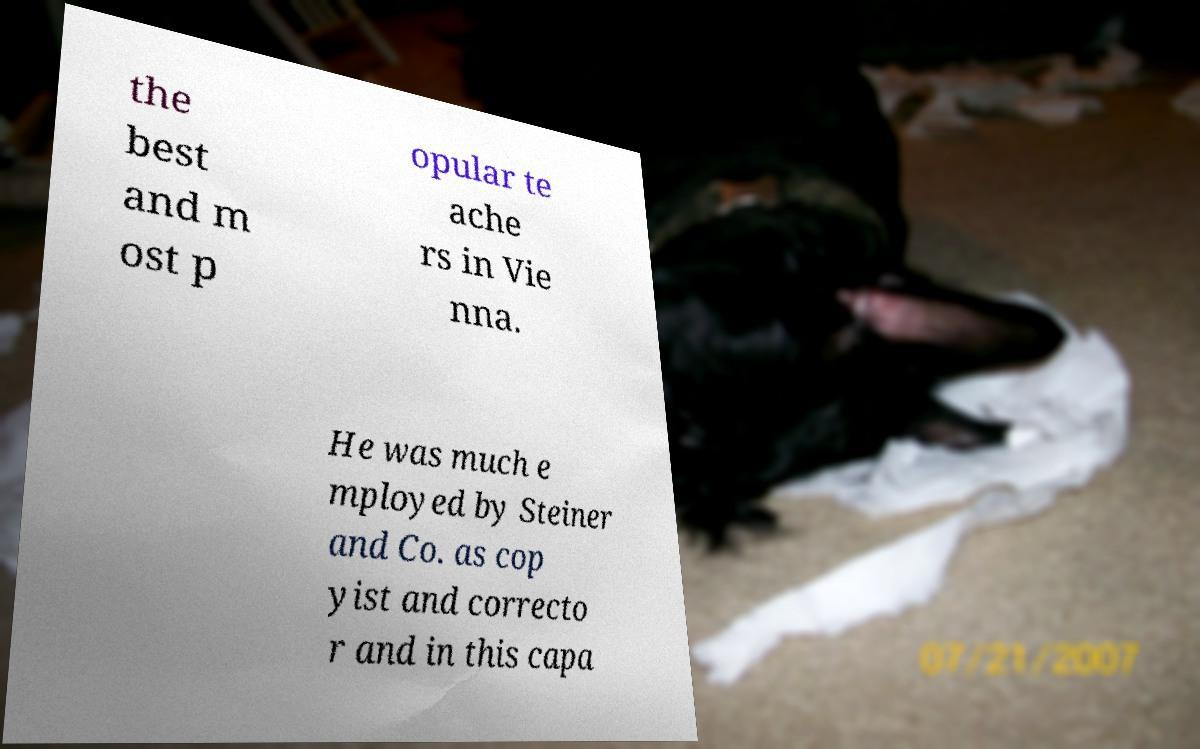Please read and relay the text visible in this image. What does it say? the best and m ost p opular te ache rs in Vie nna. He was much e mployed by Steiner and Co. as cop yist and correcto r and in this capa 